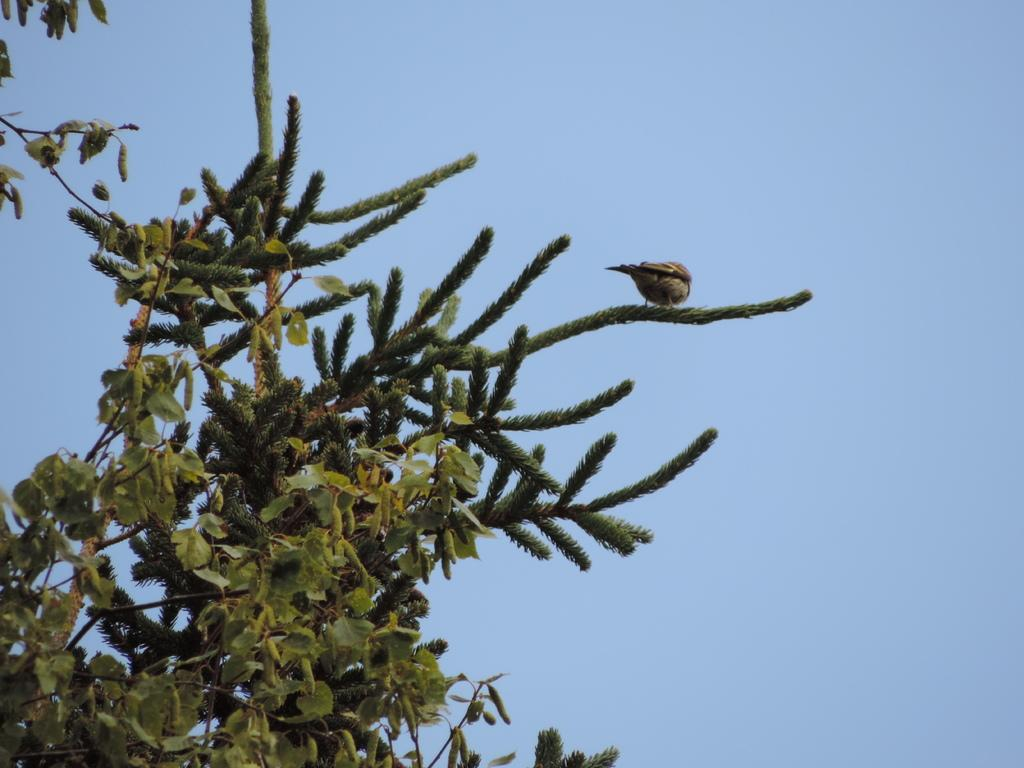What type of animal is in the image? There is a bird in the image. Where is the bird located? The bird is on a branch. What color is the background of the image? The background of the image is blue. Can you see a boy making a wish in the image? There is no boy making a wish present in the image. What type of station is the bird sitting on in the image? The bird is sitting on a branch, not a station. 